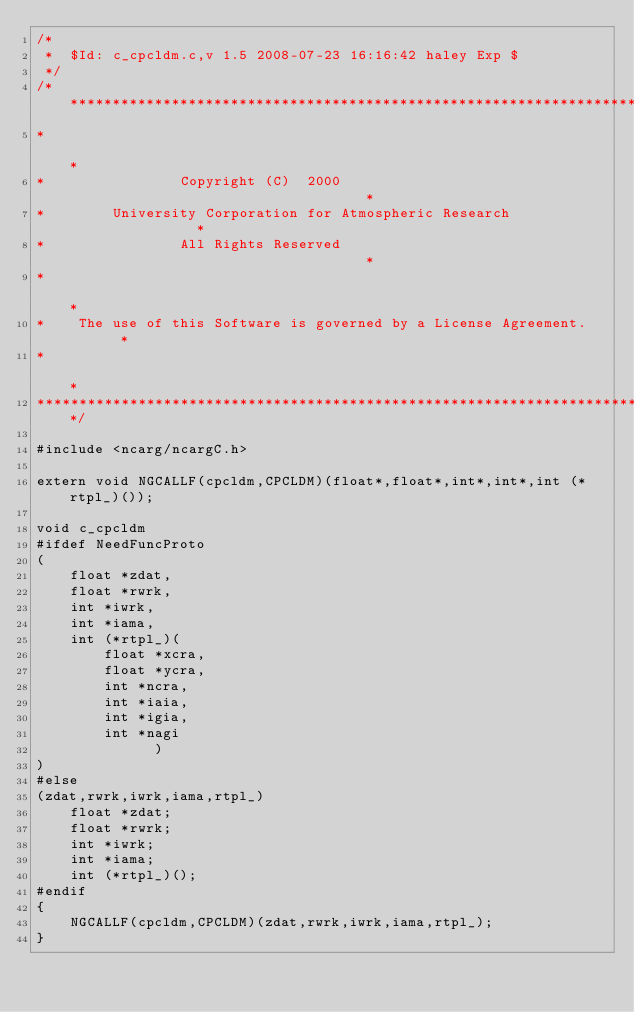<code> <loc_0><loc_0><loc_500><loc_500><_C_>/*
 *	$Id: c_cpcldm.c,v 1.5 2008-07-23 16:16:42 haley Exp $
 */
/************************************************************************
*                                                                       *
*                Copyright (C)  2000                                    *
*        University Corporation for Atmospheric Research                *
*                All Rights Reserved                                    *
*                                                                       *
*    The use of this Software is governed by a License Agreement.       *
*                                                                       *
************************************************************************/

#include <ncarg/ncargC.h>

extern void NGCALLF(cpcldm,CPCLDM)(float*,float*,int*,int*,int (*rtpl_)());

void c_cpcldm
#ifdef NeedFuncProto
(
    float *zdat,
    float *rwrk,
    int *iwrk,
    int *iama,
    int (*rtpl_)(
        float *xcra,
        float *ycra,
        int *ncra,
        int *iaia,
        int *igia,
        int *nagi
              )
)
#else
(zdat,rwrk,iwrk,iama,rtpl_)
    float *zdat;
    float *rwrk;
    int *iwrk;
    int *iama;
    int (*rtpl_)();
#endif
{
    NGCALLF(cpcldm,CPCLDM)(zdat,rwrk,iwrk,iama,rtpl_);
}
</code> 